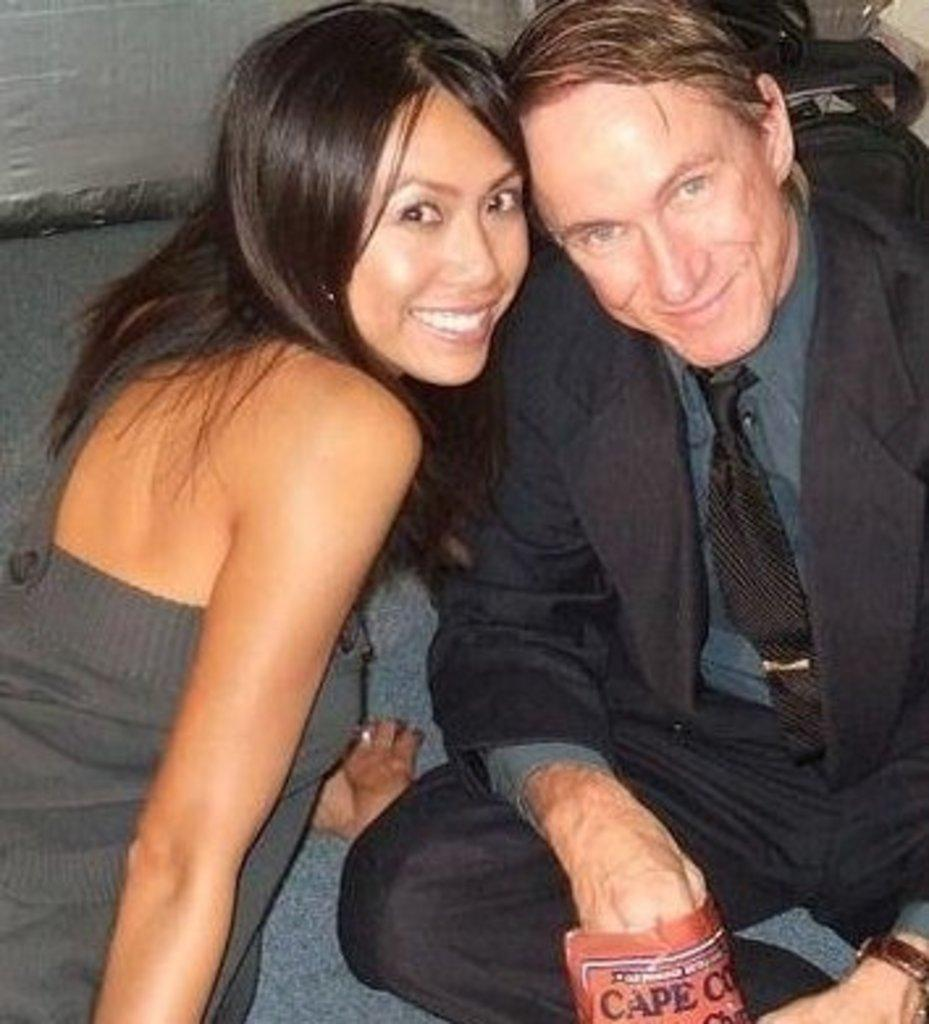How many people are present in the image? There are two people in the image, a man and a woman. What are the man and woman doing in the image? The man and woman are sitting in the center of the image. Can you describe the position of the man and woman in the image? The man and woman are sitting together in the center of the image. What type of house is visible in the background of the image? There is no house visible in the background of the image. 